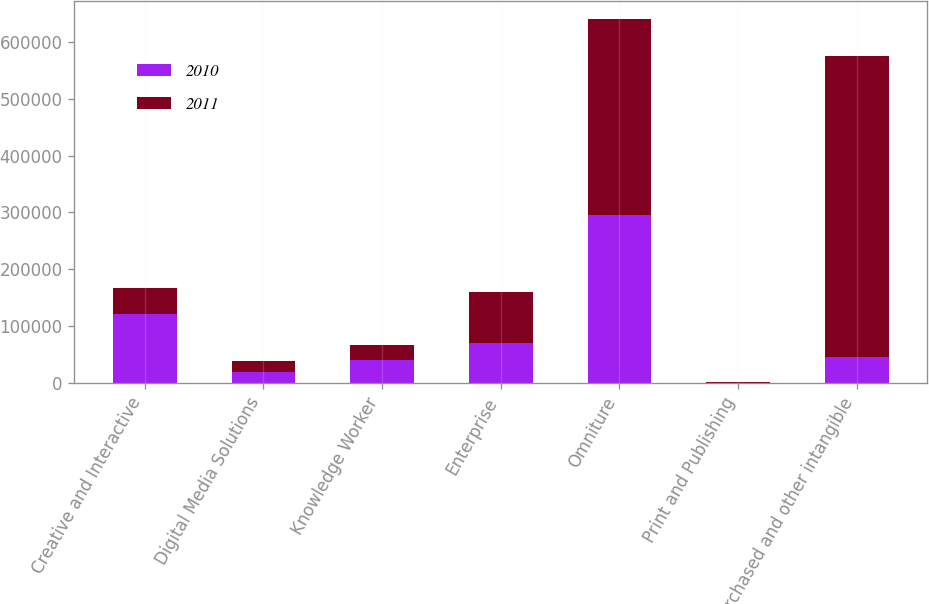Convert chart to OTSL. <chart><loc_0><loc_0><loc_500><loc_500><stacked_bar_chart><ecel><fcel>Creative and Interactive<fcel>Digital Media Solutions<fcel>Knowledge Worker<fcel>Enterprise<fcel>Omniture<fcel>Print and Publishing<fcel>Purchased and other intangible<nl><fcel>2010<fcel>120490<fcel>19399<fcel>39844<fcel>70986<fcel>294656<fcel>151<fcel>46017<nl><fcel>2011<fcel>46017<fcel>19895<fcel>27582<fcel>88386<fcel>345305<fcel>1599<fcel>528784<nl></chart> 